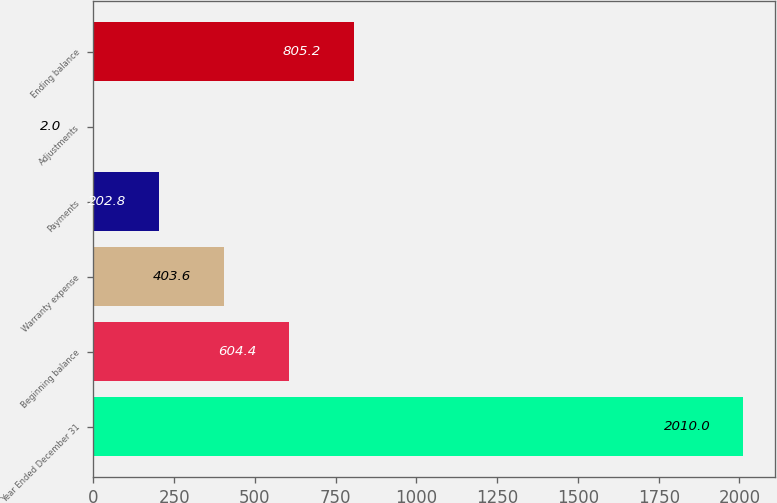Convert chart to OTSL. <chart><loc_0><loc_0><loc_500><loc_500><bar_chart><fcel>Year Ended December 31<fcel>Beginning balance<fcel>Warranty expense<fcel>Payments<fcel>Adjustments<fcel>Ending balance<nl><fcel>2010<fcel>604.4<fcel>403.6<fcel>202.8<fcel>2<fcel>805.2<nl></chart> 